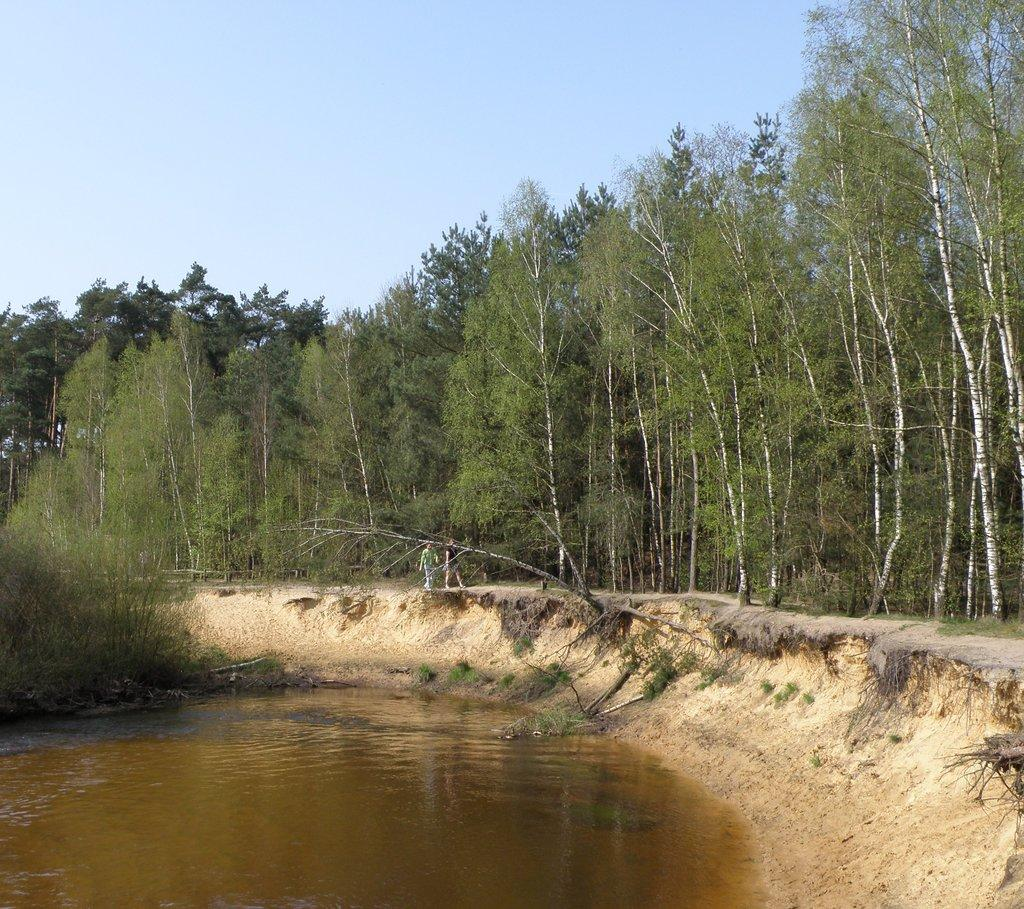What is happening in the image? There is water flowing in the image, and two people are walking. What can be seen in the background of the image? There are trees with branches and leaves in the image. What type of books are the people carrying in the image? There are no books present in the image; it features water flowing and two people walking. 